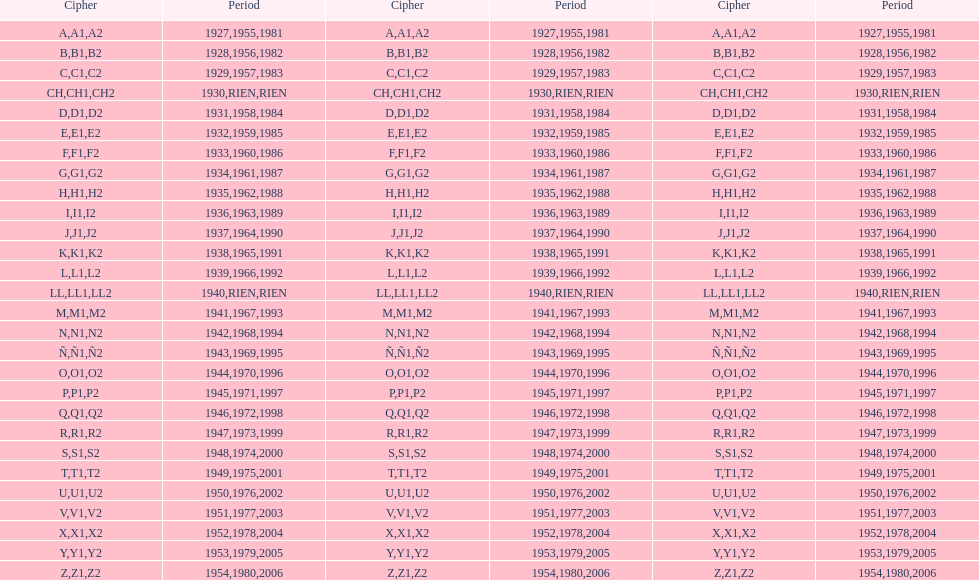How many different codes were used from 1953 to 1958? 6. 